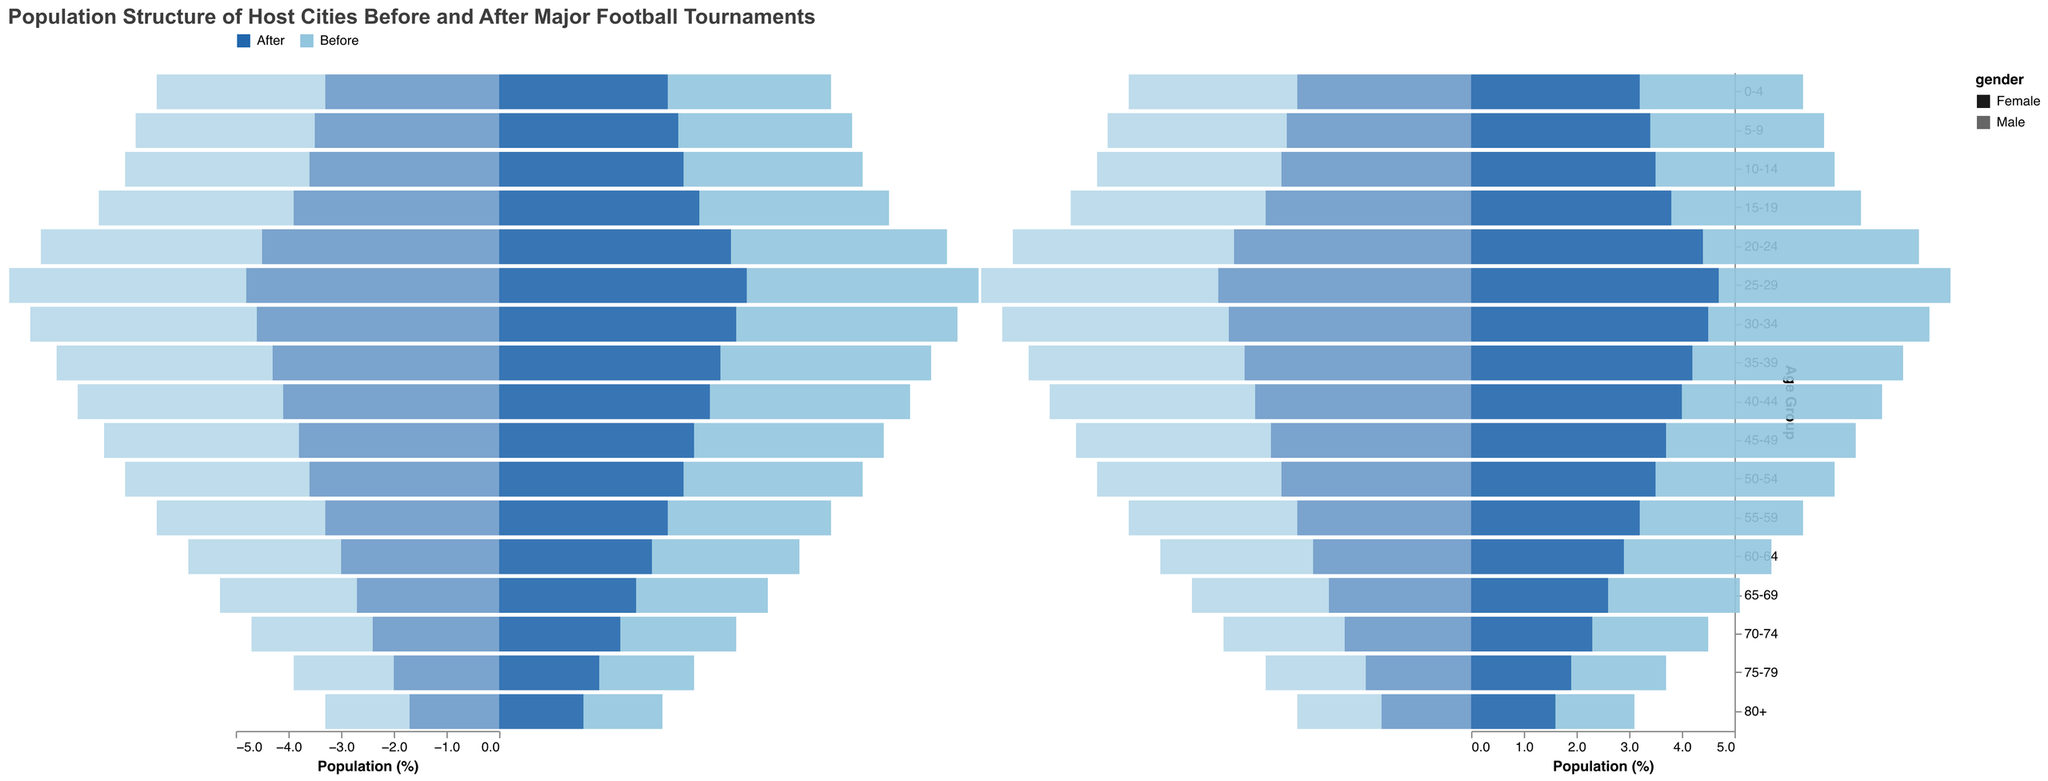What is the title of the figure? The title is usually at the top of the figure which is a standard place for indicating the main subject
Answer: Population Structure of Host Cities Before and After Major Football Tournaments What color is used to represent the population before hosting the tournaments for males? The legend at the top dictates the colors representing different periods. According to the legend for male population 'Before', it should be the first color in the range for males
Answer: #2166ac (converted to natural language: blue) Which age group has the largest increase in male population after the tournaments? By comparing the 'Male Before' and 'Male After' values for each age group, the largest jump can be spotted in the data. The group 20-24 has an increase from 4.2 to 4.5, which is a 0.3 increase, examined visually by the size of the bar segments
Answer: 20-24 What's the difference in the female population percentage for the 80+ age group before and after hosting the tournaments? Looking at the values for the Female 80+ group, Female Before is 1.5 and Female After is 1.6. The difference is calculated by subtracting the Before value from the After value: 1.6 - 1.5
Answer: 0.1 Which gender shows a greater change in the 25-29 age group after hosting the events? Examine both the male and female populations in the 25-29 age group and compare the changes. Male Before is 4.5 and Male After is 4.8 (a change of 0.3). Female Before is 4.4 and Female After is 4.7 (again a 0.3 change). Both changes are equal in magnitude thus indicating the same extent of change for both genders
Answer: Both genders show an equal change What is the average percentage change in the male population across all age groups before and after hosting the tournaments? Sum the before and after values for males across all age groups and calculate the average change. This involves taking each Before and After value, computing their differences, summing these differences, and then dividing by the number of age groups (17)
Answer: (Sum of all differences / 17) Is there any age group where the female population decreased after the tournaments? Analyzing the column Female Before and After for each age group, it seems for all age groups, the After population is either the same as Before or has increased slightly. No decreases are observed
Answer: No For the 15-19 age group, what is the percentage point change for the female population? Focus on the 15-19 age group, Female Before is 3.6 and Female After is 3.8. Calculate the percentage change using: \( (3.8 - 3.6) \)
Answer: 0.2 What general trend can you observe for both males and females as age increases? As the age ranges increase from 0-4 to 80+, the population percentages decrease for both males and females. This trend is consistent in both Before and After the tournament populations. Observing this general shape of forwards and backwards bars on the pyramid diagram
Answer: The population percentages decrease with increasing age 